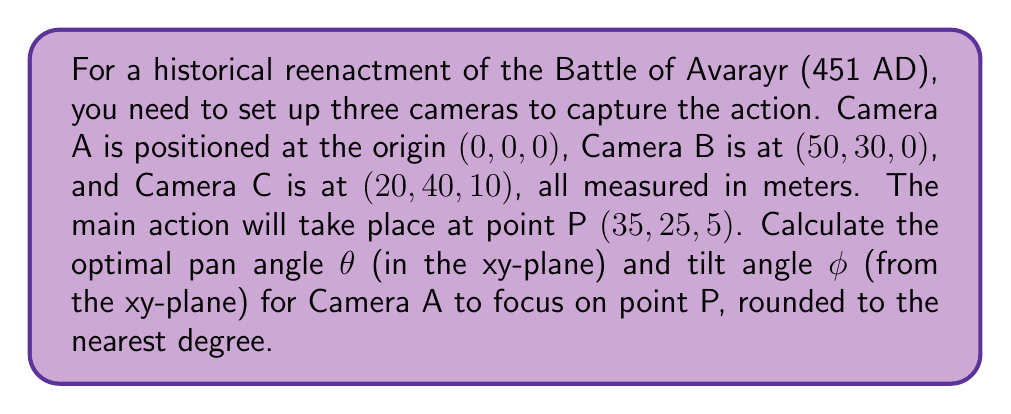Teach me how to tackle this problem. To solve this problem, we'll use vector algebra and trigonometry. Let's approach this step-by-step:

1) First, we need to find the vector from Camera A to point P. Since Camera A is at the origin, this vector is simply the coordinates of P:

   $\vec{AP} = (35, 25, 5)$

2) To calculate the pan angle θ, we only need to consider the x and y components:

   $\theta = \arctan(\frac{y}{x}) = \arctan(\frac{25}{35})$

3) Using a calculator or computer, we get:
   
   $\theta \approx 35.54°$

4) For the tilt angle φ, we need to consider the angle between $\vec{AP}$ and its projection on the xy-plane. The length of $\vec{AP}$ is:

   $|\vec{AP}| = \sqrt{35^2 + 25^2 + 5^2} = \sqrt{2150} \approx 46.37$

5) The length of the projection on the xy-plane is:

   $|\vec{AP}_{xy}| = \sqrt{35^2 + 25^2} = \sqrt{1850} \approx 43.01$

6) The tilt angle φ can be calculated using:

   $\phi = \arcsin(\frac{5}{|\vec{AP}|}) = \arcsin(\frac{5}{\sqrt{2150}})$

7) Using a calculator or computer, we get:

   $\phi \approx 6.19°$

8) Rounding both angles to the nearest degree:

   $\theta \approx 36°$
   $\phi \approx 6°$
Answer: $\theta = 36°$, $\phi = 6°$ 